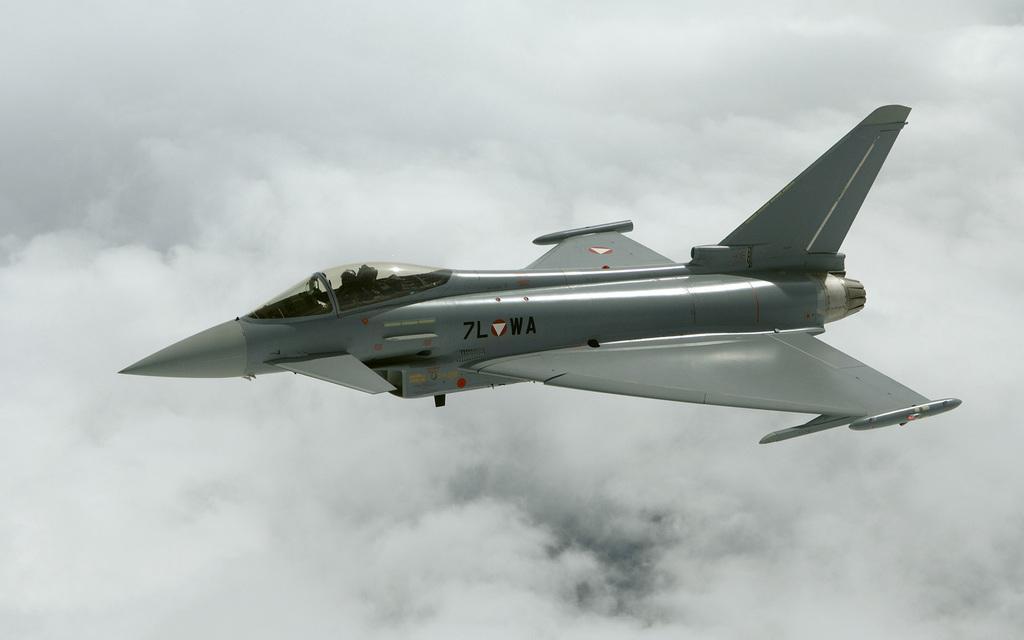How would you summarize this image in a sentence or two? This picture contains an airplane which is in grey color is flying in the sky. In the background, we see clouds. 